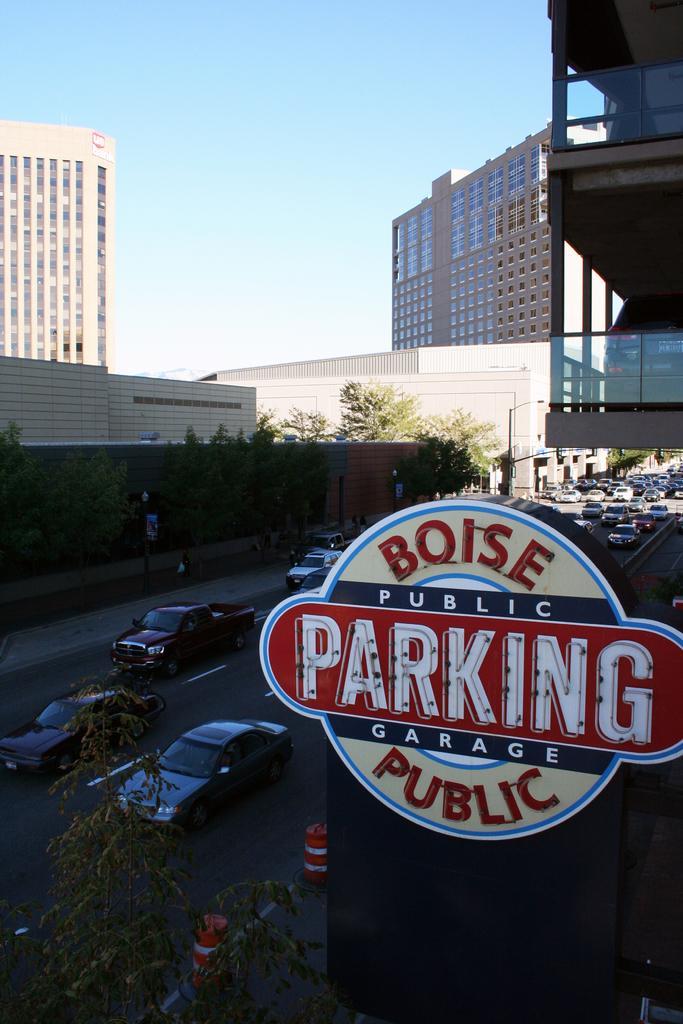Please provide a concise description of this image. In this image I can see the glass surface and a sticker attached to it. Through the glass surface I can see the road, few vehicles on the road, few trees, few buildings, the wall, few poles, a car in the building and the sky. 